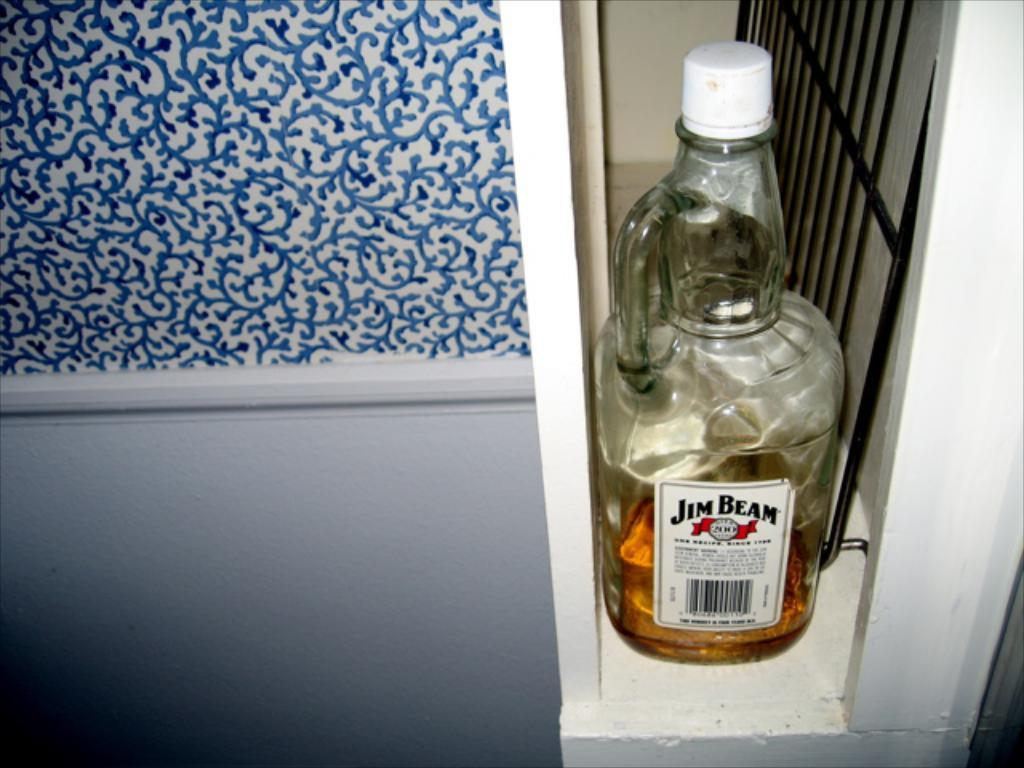<image>
Relay a brief, clear account of the picture shown. almost empty bottle of jim bean in a narrow opening 